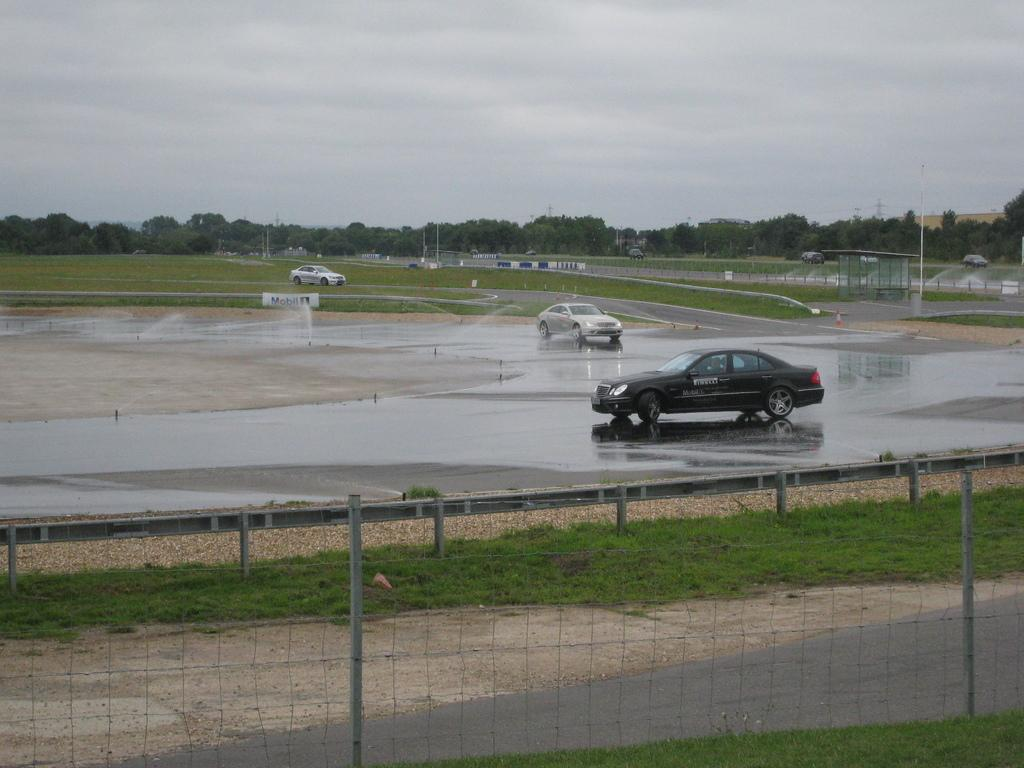What type of structure can be seen in the image? There is a fencing in the image. What is on the ground in some areas of the image? There is grass on the ground in some areas of the image. What type of vehicles are on the road in the image? There are cars on the road in the image. What type of vegetation is present in the image? There are trees in the image. What is visible at the top of the image? The sky is visible at the top of the image and appears to be cloudy. How many brothers are playing with the parcel in the image? There are no brothers or parcels present in the image. What type of treatment is being administered to the trees in the image? There is no treatment being administered to the trees in the image; they are simply standing in the background. 